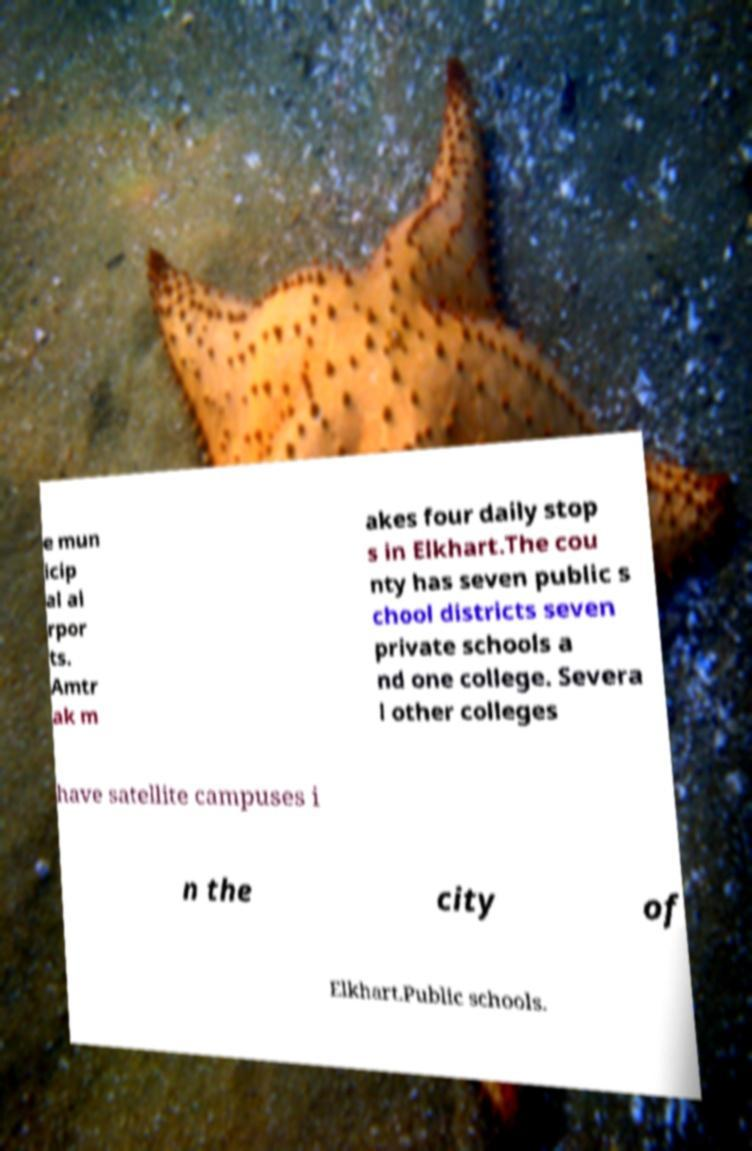There's text embedded in this image that I need extracted. Can you transcribe it verbatim? e mun icip al ai rpor ts. Amtr ak m akes four daily stop s in Elkhart.The cou nty has seven public s chool districts seven private schools a nd one college. Severa l other colleges have satellite campuses i n the city of Elkhart.Public schools. 